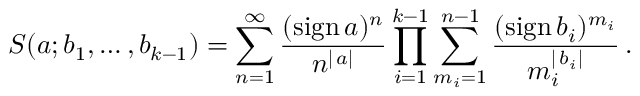<formula> <loc_0><loc_0><loc_500><loc_500>S ( a ; b _ { 1 } , \dots , b _ { k - 1 } ) = \sum _ { n = 1 } ^ { \infty } \frac { ( s i g n \, a ) ^ { n } } { n ^ { | \, a | } } \prod _ { i = 1 } ^ { k - 1 } \sum _ { m _ { i } = 1 } ^ { n - 1 } \frac { ( s i g n \, b _ { i } ) ^ { m _ { i } } } { m _ { i } ^ { | \, b _ { i } | } } \, .</formula> 